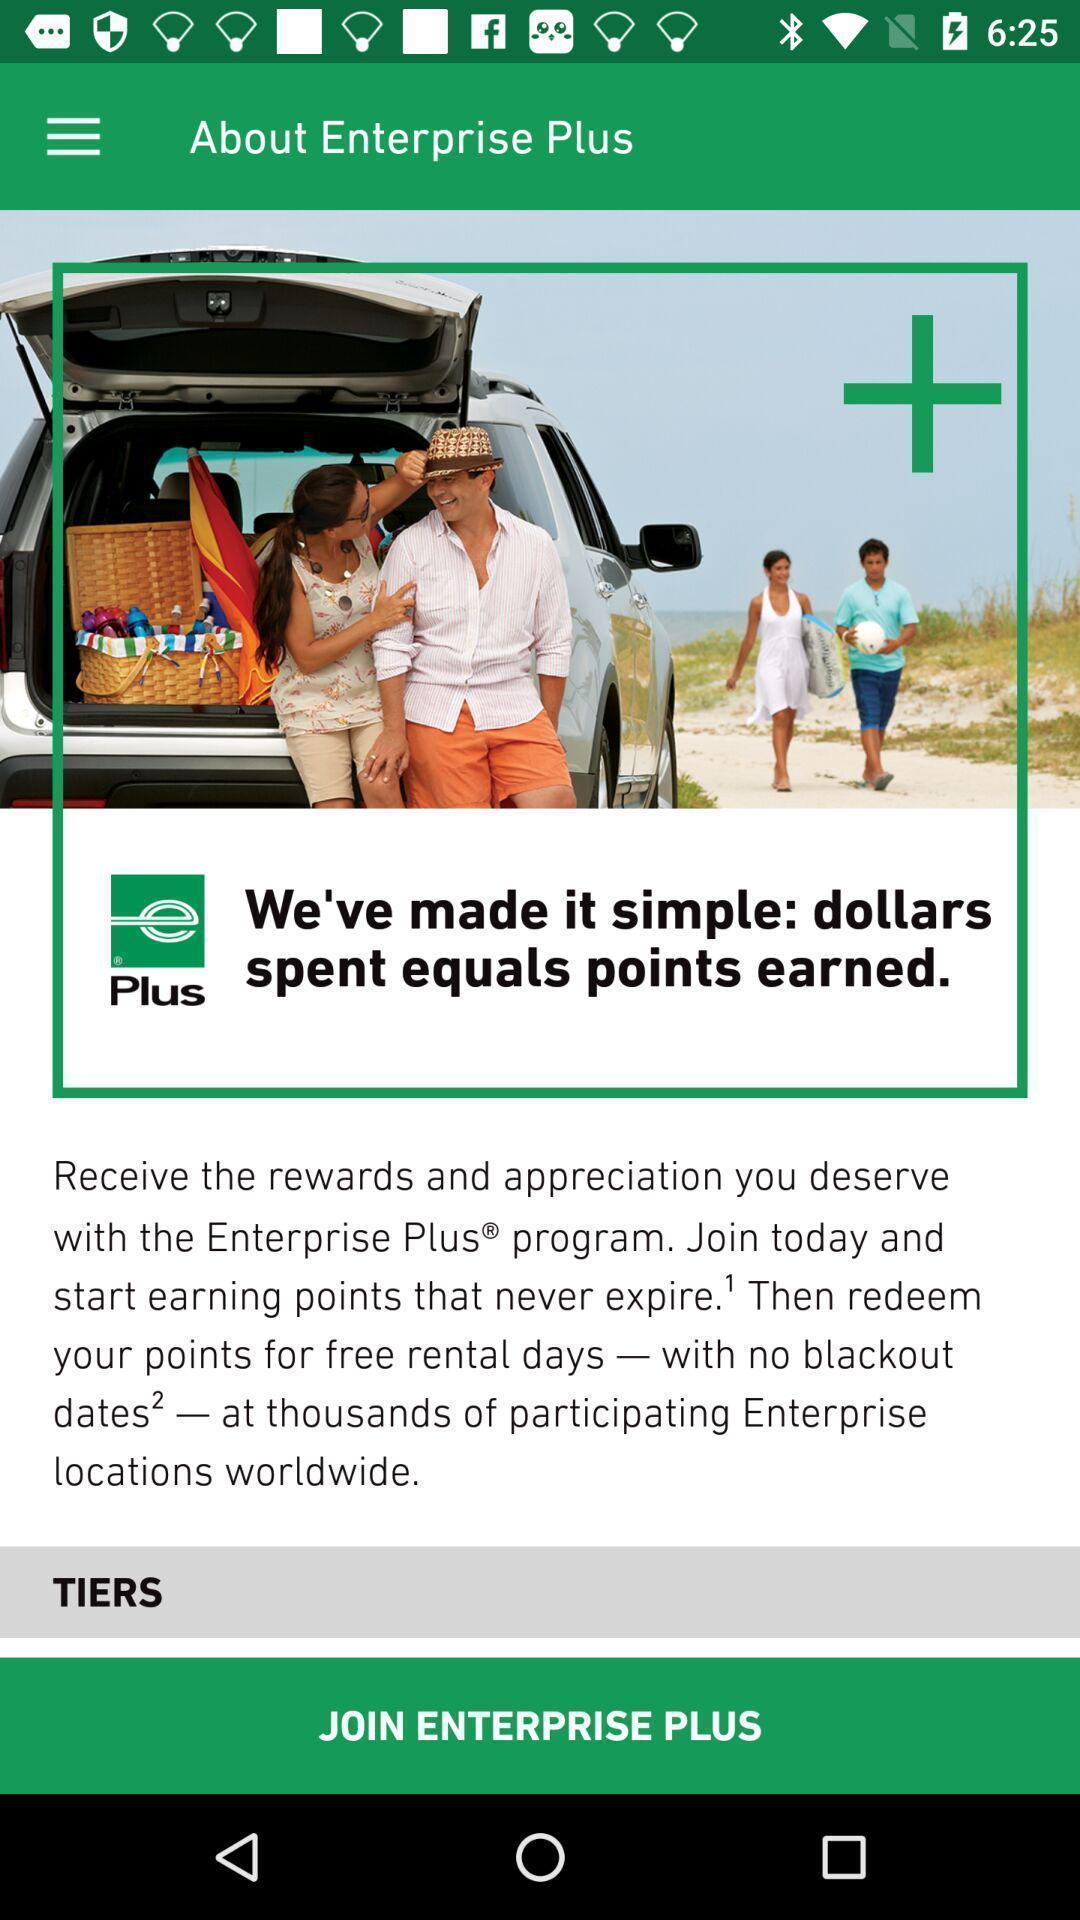Summarize the main components in this picture. Page displaying the information of the app. 